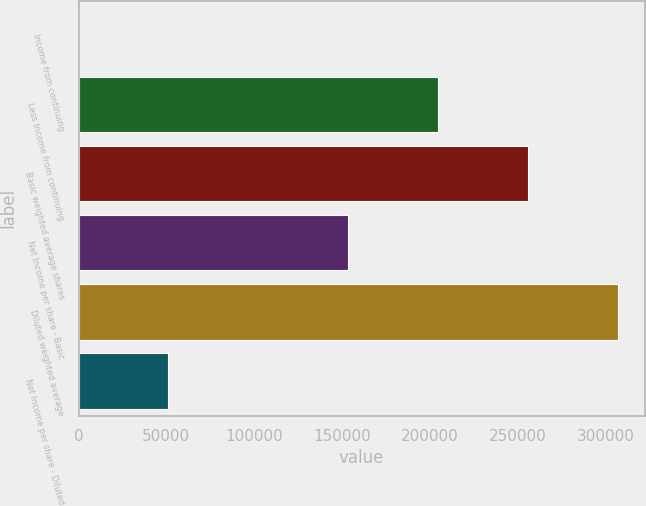<chart> <loc_0><loc_0><loc_500><loc_500><bar_chart><fcel>Income from continuing<fcel>Less Income from continuing<fcel>Basic weighted average shares<fcel>Net Income per share - Basic<fcel>Diluted weighted average<fcel>Net Income per share - Diluted<nl><fcel>4.35<fcel>204565<fcel>255705<fcel>153425<fcel>306845<fcel>51144.5<nl></chart> 